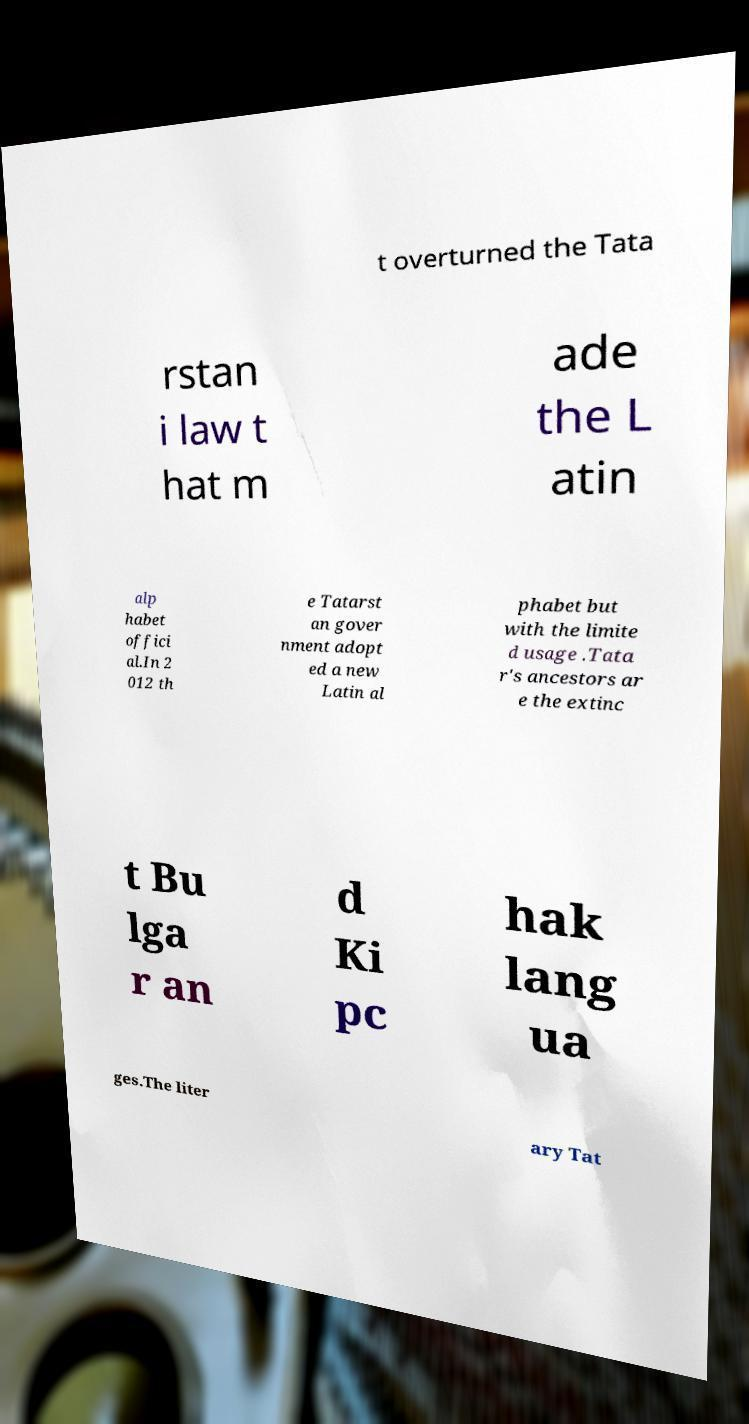I need the written content from this picture converted into text. Can you do that? t overturned the Tata rstan i law t hat m ade the L atin alp habet offici al.In 2 012 th e Tatarst an gover nment adopt ed a new Latin al phabet but with the limite d usage .Tata r's ancestors ar e the extinc t Bu lga r an d Ki pc hak lang ua ges.The liter ary Tat 